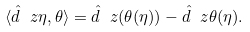<formula> <loc_0><loc_0><loc_500><loc_500>\langle \hat { d } _ { \ } z \eta , \theta \rangle = \hat { d } _ { \ } z ( \theta ( \eta ) ) - \hat { d } _ { \ } z \theta ( \eta ) .</formula> 